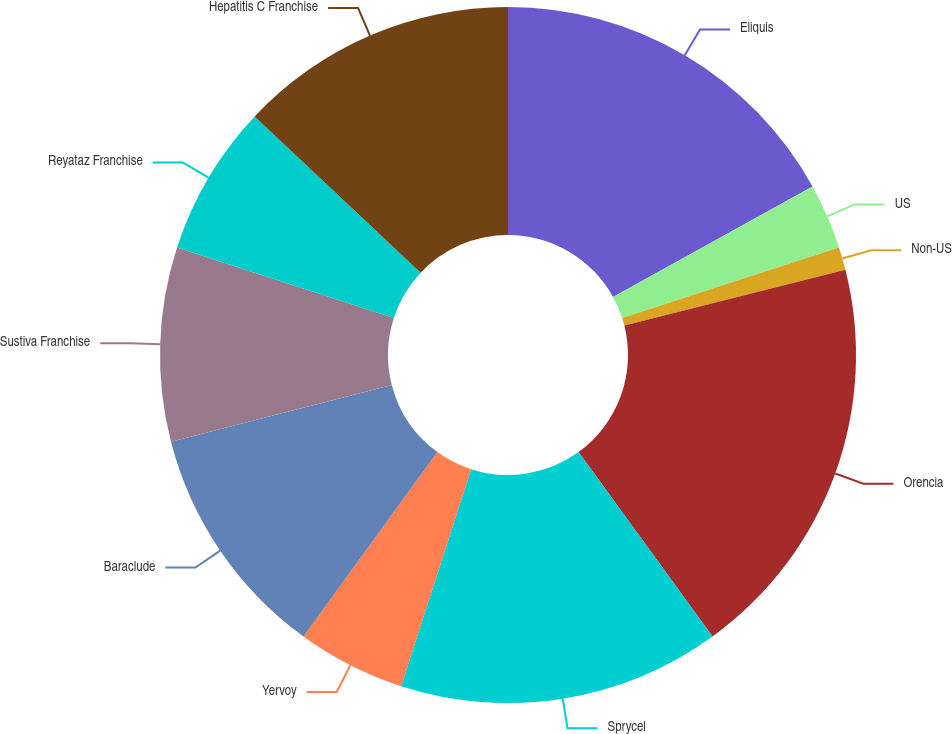Convert chart. <chart><loc_0><loc_0><loc_500><loc_500><pie_chart><fcel>Eliquis<fcel>US<fcel>Non-US<fcel>Orencia<fcel>Sprycel<fcel>Yervoy<fcel>Baraclude<fcel>Sustiva Franchise<fcel>Reyataz Franchise<fcel>Hepatitis C Franchise<nl><fcel>16.96%<fcel>3.04%<fcel>1.06%<fcel>18.94%<fcel>14.97%<fcel>5.03%<fcel>10.99%<fcel>9.01%<fcel>7.02%<fcel>12.98%<nl></chart> 